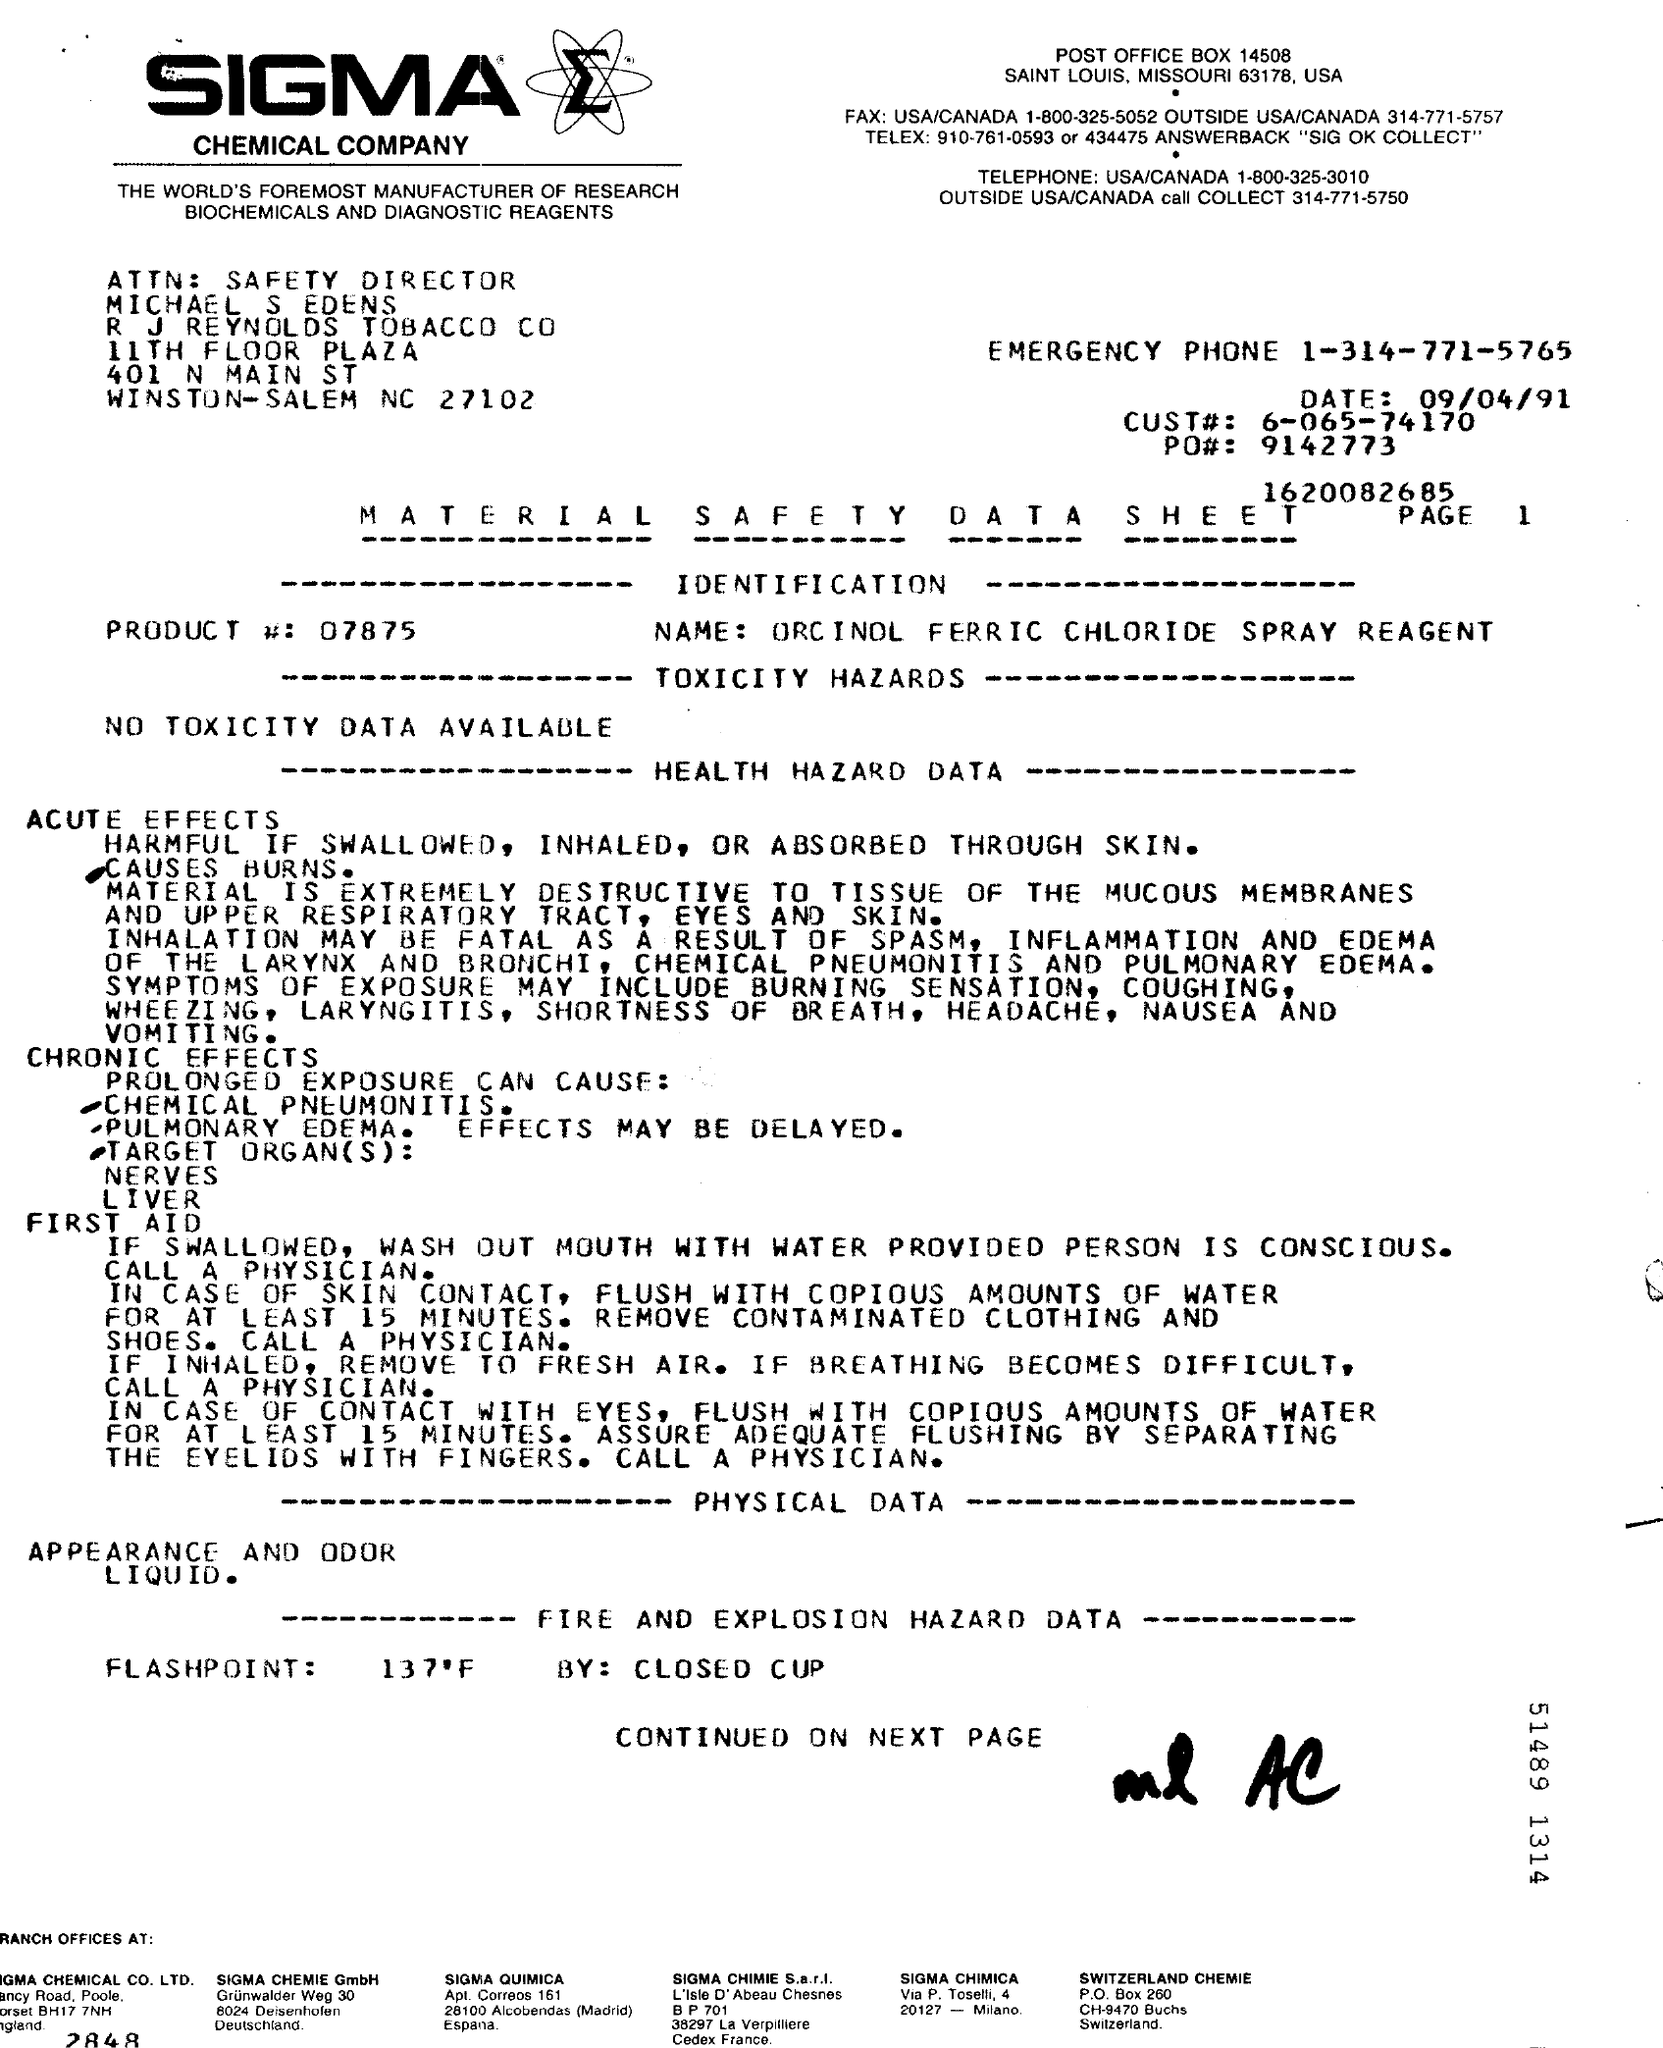Indicate a few pertinent items in this graphic. The product number provided in the document is 07875... The CUST# mentioned in the document is 6-065-74170. The Safety Director of R.J. Reynolds Tobacco Company is named Michael S. Edens. The Material Safety Data Sheet belongs to the SIGMA CHEMICAL COMPANY. The product name mentioned in the document is ORCINOL FERRIC CHLORIDE SPRAY REAGENT. 